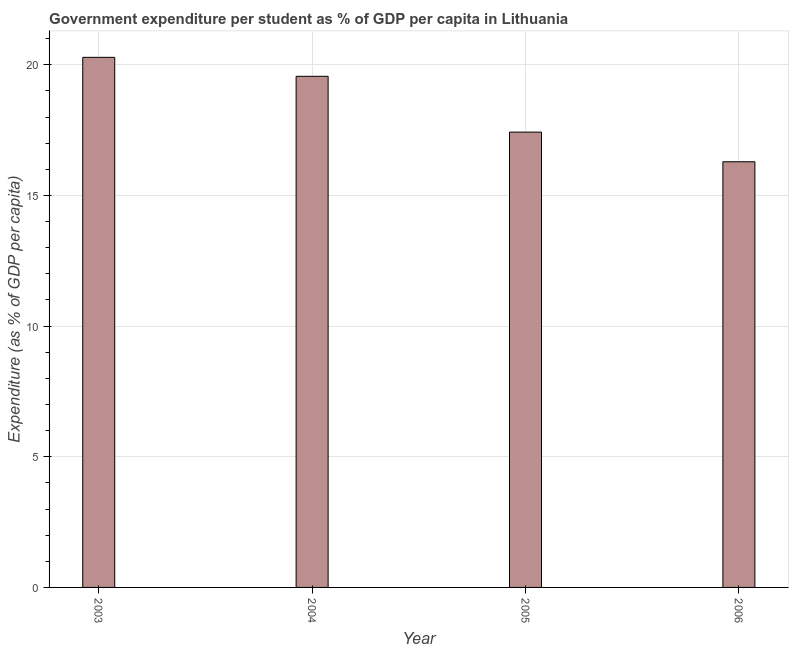What is the title of the graph?
Give a very brief answer. Government expenditure per student as % of GDP per capita in Lithuania. What is the label or title of the Y-axis?
Offer a terse response. Expenditure (as % of GDP per capita). What is the government expenditure per student in 2006?
Offer a very short reply. 16.29. Across all years, what is the maximum government expenditure per student?
Your answer should be compact. 20.29. Across all years, what is the minimum government expenditure per student?
Provide a succinct answer. 16.29. In which year was the government expenditure per student minimum?
Your response must be concise. 2006. What is the sum of the government expenditure per student?
Give a very brief answer. 73.56. What is the difference between the government expenditure per student in 2004 and 2006?
Offer a very short reply. 3.27. What is the average government expenditure per student per year?
Make the answer very short. 18.39. What is the median government expenditure per student?
Offer a terse response. 18.49. In how many years, is the government expenditure per student greater than 12 %?
Provide a short and direct response. 4. What is the ratio of the government expenditure per student in 2004 to that in 2005?
Offer a terse response. 1.12. Is the difference between the government expenditure per student in 2005 and 2006 greater than the difference between any two years?
Offer a terse response. No. What is the difference between the highest and the second highest government expenditure per student?
Ensure brevity in your answer.  0.73. What is the difference between the highest and the lowest government expenditure per student?
Offer a very short reply. 4. Are all the bars in the graph horizontal?
Keep it short and to the point. No. How many years are there in the graph?
Your response must be concise. 4. Are the values on the major ticks of Y-axis written in scientific E-notation?
Provide a succinct answer. No. What is the Expenditure (as % of GDP per capita) in 2003?
Ensure brevity in your answer.  20.29. What is the Expenditure (as % of GDP per capita) of 2004?
Provide a succinct answer. 19.56. What is the Expenditure (as % of GDP per capita) in 2005?
Make the answer very short. 17.42. What is the Expenditure (as % of GDP per capita) of 2006?
Your response must be concise. 16.29. What is the difference between the Expenditure (as % of GDP per capita) in 2003 and 2004?
Offer a terse response. 0.73. What is the difference between the Expenditure (as % of GDP per capita) in 2003 and 2005?
Ensure brevity in your answer.  2.86. What is the difference between the Expenditure (as % of GDP per capita) in 2003 and 2006?
Provide a succinct answer. 4. What is the difference between the Expenditure (as % of GDP per capita) in 2004 and 2005?
Keep it short and to the point. 2.14. What is the difference between the Expenditure (as % of GDP per capita) in 2004 and 2006?
Provide a short and direct response. 3.27. What is the difference between the Expenditure (as % of GDP per capita) in 2005 and 2006?
Your response must be concise. 1.13. What is the ratio of the Expenditure (as % of GDP per capita) in 2003 to that in 2004?
Your answer should be compact. 1.04. What is the ratio of the Expenditure (as % of GDP per capita) in 2003 to that in 2005?
Offer a terse response. 1.16. What is the ratio of the Expenditure (as % of GDP per capita) in 2003 to that in 2006?
Provide a short and direct response. 1.25. What is the ratio of the Expenditure (as % of GDP per capita) in 2004 to that in 2005?
Your answer should be compact. 1.12. What is the ratio of the Expenditure (as % of GDP per capita) in 2004 to that in 2006?
Make the answer very short. 1.2. What is the ratio of the Expenditure (as % of GDP per capita) in 2005 to that in 2006?
Your answer should be very brief. 1.07. 